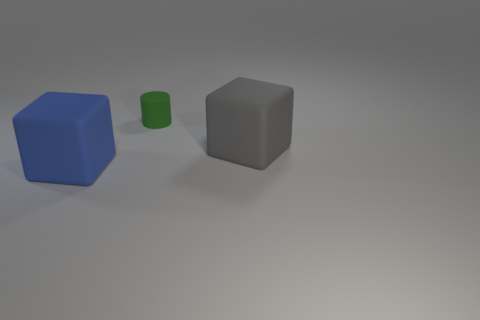Are there any matte cylinders of the same color as the tiny matte object?
Offer a very short reply. No. Is the number of blue things that are to the right of the small rubber thing less than the number of small green cylinders to the right of the large gray block?
Keep it short and to the point. No. There is a object that is both to the left of the large gray matte object and in front of the cylinder; what is its material?
Offer a very short reply. Rubber. Do the large blue matte object and the large rubber object that is on the right side of the green thing have the same shape?
Provide a short and direct response. Yes. What number of other things are the same size as the green object?
Give a very brief answer. 0. Is the number of large blue balls greater than the number of blocks?
Ensure brevity in your answer.  No. What number of blocks are in front of the gray block and behind the blue matte thing?
Provide a succinct answer. 0. What is the shape of the object behind the large gray block that is on the right side of the tiny green matte cylinder behind the big blue cube?
Ensure brevity in your answer.  Cylinder. Are there any other things that are the same shape as the green object?
Your answer should be compact. No. How many blocks are large cyan rubber objects or large objects?
Your answer should be compact. 2. 